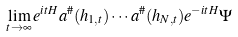<formula> <loc_0><loc_0><loc_500><loc_500>\lim _ { t \to \infty } e ^ { i t H } a ^ { \# } ( h _ { 1 , t } ) \cdots a ^ { \# } ( h _ { N , t } ) e ^ { - i t H } \Psi</formula> 